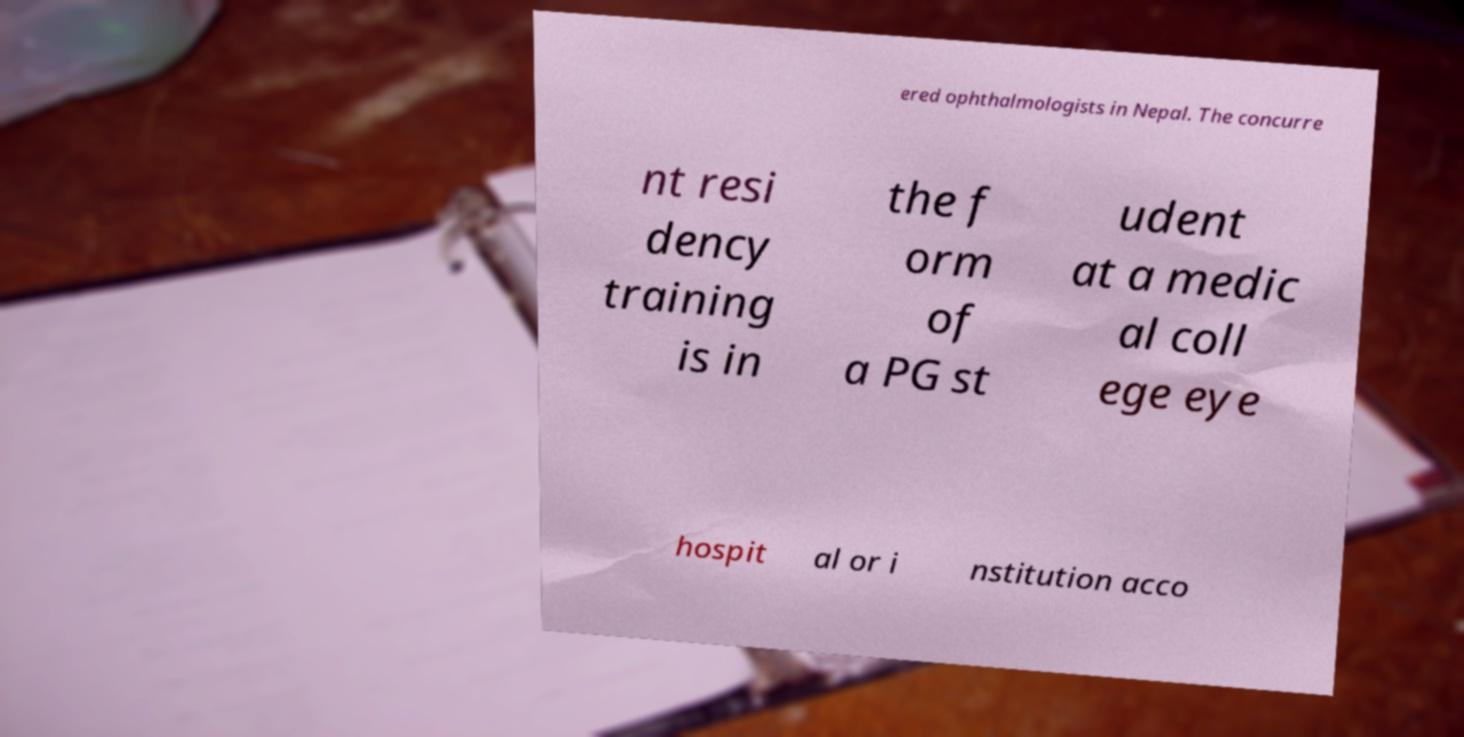Can you read and provide the text displayed in the image?This photo seems to have some interesting text. Can you extract and type it out for me? ered ophthalmologists in Nepal. The concurre nt resi dency training is in the f orm of a PG st udent at a medic al coll ege eye hospit al or i nstitution acco 